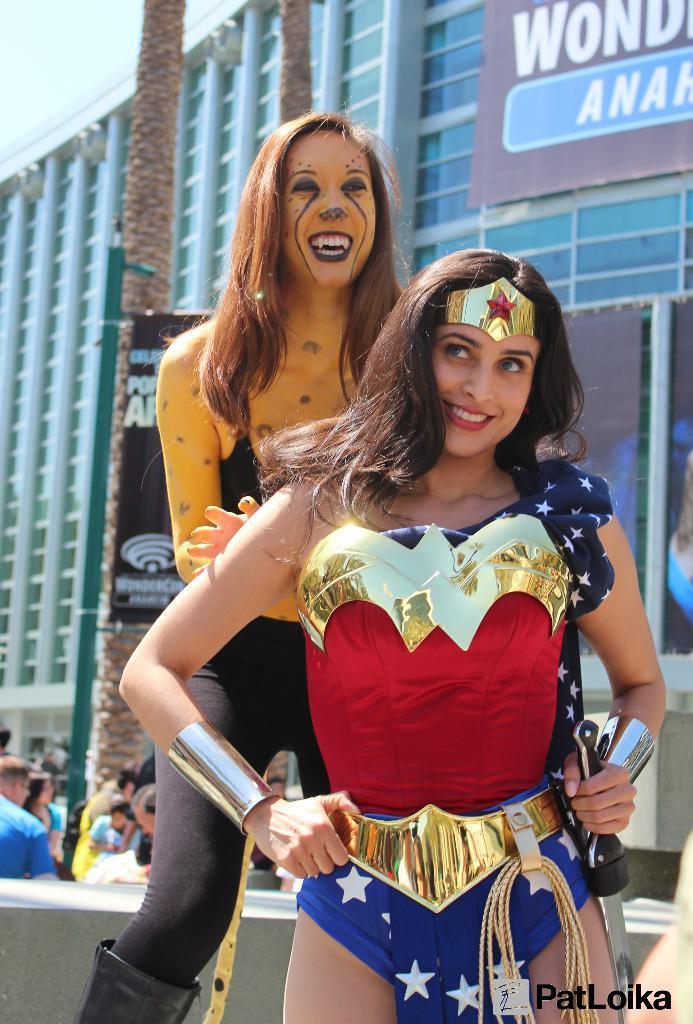Please provide a concise description of this image. In the image there are two ladies with costumes. Behind them there are few people and also there are banners. There are tree trunks. In the background there is a building with glasses and a banner. 